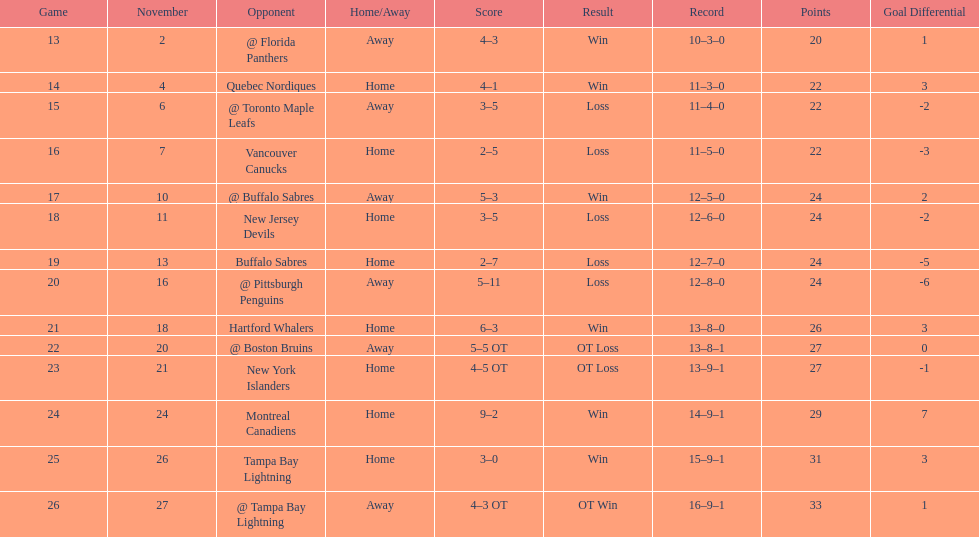Were the new jersey devils in last place according to the chart? No. 